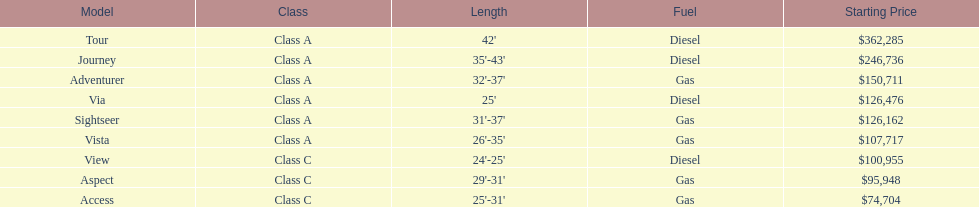Which model has the most affordable starting price? Access. Which model has the second highest starting price? Journey. Which model has the most expensive price in the winnebago industry? Tour. 